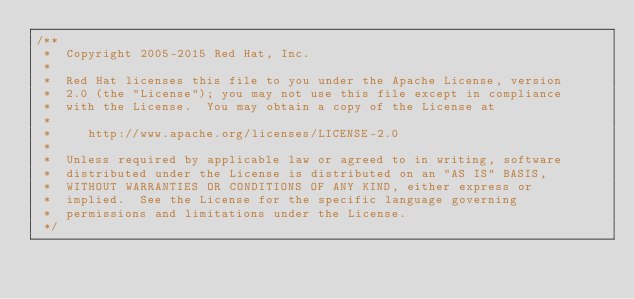Convert code to text. <code><loc_0><loc_0><loc_500><loc_500><_Java_>/**
 *  Copyright 2005-2015 Red Hat, Inc.
 *
 *  Red Hat licenses this file to you under the Apache License, version
 *  2.0 (the "License"); you may not use this file except in compliance
 *  with the License.  You may obtain a copy of the License at
 *
 *     http://www.apache.org/licenses/LICENSE-2.0
 *
 *  Unless required by applicable law or agreed to in writing, software
 *  distributed under the License is distributed on an "AS IS" BASIS,
 *  WITHOUT WARRANTIES OR CONDITIONS OF ANY KIND, either express or
 *  implied.  See the License for the specific language governing
 *  permissions and limitations under the License.
 */</code> 